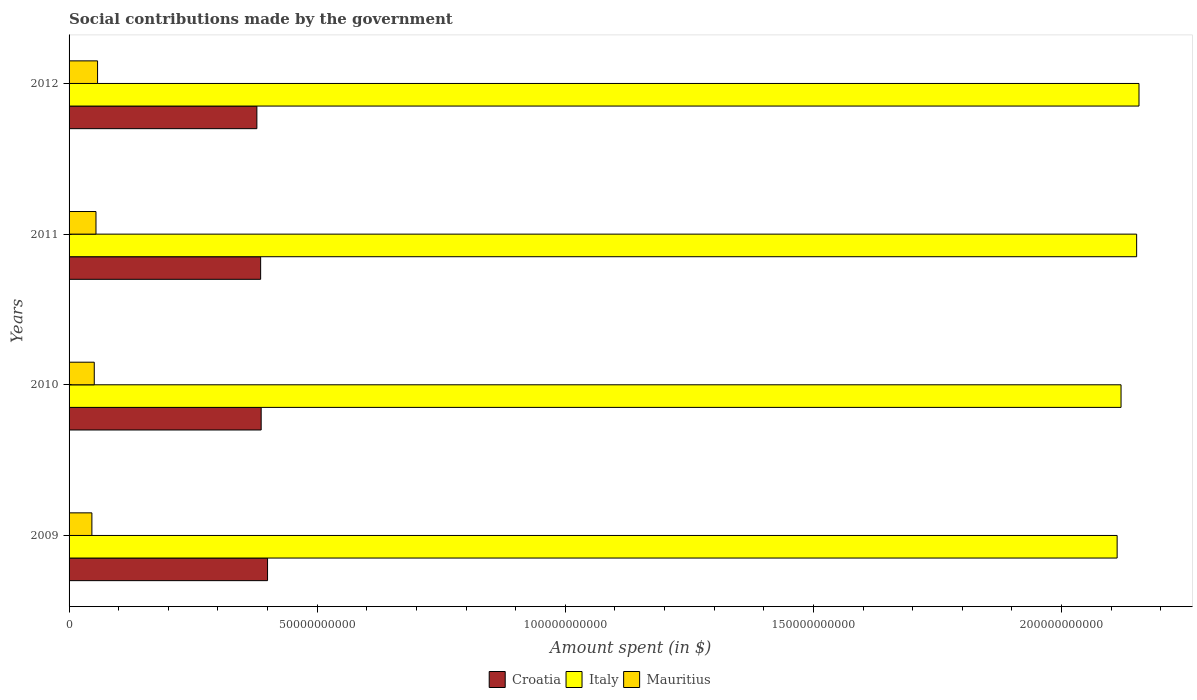How many groups of bars are there?
Give a very brief answer. 4. What is the label of the 4th group of bars from the top?
Give a very brief answer. 2009. What is the amount spent on social contributions in Italy in 2012?
Provide a succinct answer. 2.16e+11. Across all years, what is the maximum amount spent on social contributions in Croatia?
Your answer should be compact. 4.00e+1. Across all years, what is the minimum amount spent on social contributions in Croatia?
Provide a short and direct response. 3.78e+1. In which year was the amount spent on social contributions in Croatia maximum?
Keep it short and to the point. 2009. In which year was the amount spent on social contributions in Mauritius minimum?
Provide a short and direct response. 2009. What is the total amount spent on social contributions in Mauritius in the graph?
Your answer should be compact. 2.08e+1. What is the difference between the amount spent on social contributions in Mauritius in 2009 and that in 2012?
Offer a very short reply. -1.15e+09. What is the difference between the amount spent on social contributions in Croatia in 2010 and the amount spent on social contributions in Italy in 2009?
Offer a very short reply. -1.72e+11. What is the average amount spent on social contributions in Mauritius per year?
Give a very brief answer. 5.21e+09. In the year 2012, what is the difference between the amount spent on social contributions in Italy and amount spent on social contributions in Mauritius?
Your answer should be compact. 2.10e+11. What is the ratio of the amount spent on social contributions in Croatia in 2010 to that in 2012?
Ensure brevity in your answer.  1.02. What is the difference between the highest and the second highest amount spent on social contributions in Croatia?
Provide a short and direct response. 1.28e+09. What is the difference between the highest and the lowest amount spent on social contributions in Italy?
Offer a terse response. 4.40e+09. In how many years, is the amount spent on social contributions in Mauritius greater than the average amount spent on social contributions in Mauritius taken over all years?
Offer a very short reply. 2. Is the sum of the amount spent on social contributions in Mauritius in 2009 and 2010 greater than the maximum amount spent on social contributions in Croatia across all years?
Keep it short and to the point. No. What does the 1st bar from the top in 2009 represents?
Your answer should be very brief. Mauritius. What does the 1st bar from the bottom in 2010 represents?
Your response must be concise. Croatia. Is it the case that in every year, the sum of the amount spent on social contributions in Italy and amount spent on social contributions in Croatia is greater than the amount spent on social contributions in Mauritius?
Offer a very short reply. Yes. Does the graph contain any zero values?
Offer a terse response. No. How many legend labels are there?
Offer a terse response. 3. What is the title of the graph?
Offer a terse response. Social contributions made by the government. Does "Cameroon" appear as one of the legend labels in the graph?
Ensure brevity in your answer.  No. What is the label or title of the X-axis?
Provide a succinct answer. Amount spent (in $). What is the label or title of the Y-axis?
Ensure brevity in your answer.  Years. What is the Amount spent (in $) in Croatia in 2009?
Ensure brevity in your answer.  4.00e+1. What is the Amount spent (in $) in Italy in 2009?
Offer a terse response. 2.11e+11. What is the Amount spent (in $) in Mauritius in 2009?
Your answer should be very brief. 4.60e+09. What is the Amount spent (in $) in Croatia in 2010?
Provide a short and direct response. 3.87e+1. What is the Amount spent (in $) in Italy in 2010?
Ensure brevity in your answer.  2.12e+11. What is the Amount spent (in $) of Mauritius in 2010?
Your answer should be compact. 5.08e+09. What is the Amount spent (in $) of Croatia in 2011?
Offer a terse response. 3.86e+1. What is the Amount spent (in $) in Italy in 2011?
Your answer should be compact. 2.15e+11. What is the Amount spent (in $) in Mauritius in 2011?
Make the answer very short. 5.42e+09. What is the Amount spent (in $) of Croatia in 2012?
Provide a succinct answer. 3.78e+1. What is the Amount spent (in $) in Italy in 2012?
Provide a succinct answer. 2.16e+11. What is the Amount spent (in $) in Mauritius in 2012?
Provide a short and direct response. 5.74e+09. Across all years, what is the maximum Amount spent (in $) of Croatia?
Your answer should be compact. 4.00e+1. Across all years, what is the maximum Amount spent (in $) of Italy?
Your answer should be compact. 2.16e+11. Across all years, what is the maximum Amount spent (in $) of Mauritius?
Give a very brief answer. 5.74e+09. Across all years, what is the minimum Amount spent (in $) in Croatia?
Offer a terse response. 3.78e+1. Across all years, what is the minimum Amount spent (in $) of Italy?
Your answer should be compact. 2.11e+11. Across all years, what is the minimum Amount spent (in $) in Mauritius?
Offer a terse response. 4.60e+09. What is the total Amount spent (in $) of Croatia in the graph?
Make the answer very short. 1.55e+11. What is the total Amount spent (in $) of Italy in the graph?
Your response must be concise. 8.54e+11. What is the total Amount spent (in $) of Mauritius in the graph?
Keep it short and to the point. 2.08e+1. What is the difference between the Amount spent (in $) in Croatia in 2009 and that in 2010?
Your response must be concise. 1.28e+09. What is the difference between the Amount spent (in $) in Italy in 2009 and that in 2010?
Your response must be concise. -7.86e+08. What is the difference between the Amount spent (in $) in Mauritius in 2009 and that in 2010?
Provide a succinct answer. -4.80e+08. What is the difference between the Amount spent (in $) in Croatia in 2009 and that in 2011?
Provide a succinct answer. 1.39e+09. What is the difference between the Amount spent (in $) of Italy in 2009 and that in 2011?
Make the answer very short. -3.93e+09. What is the difference between the Amount spent (in $) of Mauritius in 2009 and that in 2011?
Provide a short and direct response. -8.24e+08. What is the difference between the Amount spent (in $) in Croatia in 2009 and that in 2012?
Ensure brevity in your answer.  2.15e+09. What is the difference between the Amount spent (in $) of Italy in 2009 and that in 2012?
Provide a succinct answer. -4.40e+09. What is the difference between the Amount spent (in $) in Mauritius in 2009 and that in 2012?
Your answer should be very brief. -1.15e+09. What is the difference between the Amount spent (in $) of Croatia in 2010 and that in 2011?
Give a very brief answer. 1.07e+08. What is the difference between the Amount spent (in $) of Italy in 2010 and that in 2011?
Keep it short and to the point. -3.14e+09. What is the difference between the Amount spent (in $) in Mauritius in 2010 and that in 2011?
Give a very brief answer. -3.45e+08. What is the difference between the Amount spent (in $) of Croatia in 2010 and that in 2012?
Give a very brief answer. 8.67e+08. What is the difference between the Amount spent (in $) in Italy in 2010 and that in 2012?
Provide a short and direct response. -3.62e+09. What is the difference between the Amount spent (in $) of Mauritius in 2010 and that in 2012?
Offer a terse response. -6.65e+08. What is the difference between the Amount spent (in $) in Croatia in 2011 and that in 2012?
Your answer should be very brief. 7.59e+08. What is the difference between the Amount spent (in $) in Italy in 2011 and that in 2012?
Your response must be concise. -4.74e+08. What is the difference between the Amount spent (in $) of Mauritius in 2011 and that in 2012?
Your answer should be compact. -3.21e+08. What is the difference between the Amount spent (in $) of Croatia in 2009 and the Amount spent (in $) of Italy in 2010?
Ensure brevity in your answer.  -1.72e+11. What is the difference between the Amount spent (in $) in Croatia in 2009 and the Amount spent (in $) in Mauritius in 2010?
Keep it short and to the point. 3.49e+1. What is the difference between the Amount spent (in $) in Italy in 2009 and the Amount spent (in $) in Mauritius in 2010?
Provide a succinct answer. 2.06e+11. What is the difference between the Amount spent (in $) in Croatia in 2009 and the Amount spent (in $) in Italy in 2011?
Offer a very short reply. -1.75e+11. What is the difference between the Amount spent (in $) of Croatia in 2009 and the Amount spent (in $) of Mauritius in 2011?
Keep it short and to the point. 3.46e+1. What is the difference between the Amount spent (in $) in Italy in 2009 and the Amount spent (in $) in Mauritius in 2011?
Your answer should be compact. 2.06e+11. What is the difference between the Amount spent (in $) of Croatia in 2009 and the Amount spent (in $) of Italy in 2012?
Keep it short and to the point. -1.76e+11. What is the difference between the Amount spent (in $) in Croatia in 2009 and the Amount spent (in $) in Mauritius in 2012?
Your response must be concise. 3.43e+1. What is the difference between the Amount spent (in $) in Italy in 2009 and the Amount spent (in $) in Mauritius in 2012?
Provide a short and direct response. 2.05e+11. What is the difference between the Amount spent (in $) in Croatia in 2010 and the Amount spent (in $) in Italy in 2011?
Keep it short and to the point. -1.76e+11. What is the difference between the Amount spent (in $) of Croatia in 2010 and the Amount spent (in $) of Mauritius in 2011?
Give a very brief answer. 3.33e+1. What is the difference between the Amount spent (in $) in Italy in 2010 and the Amount spent (in $) in Mauritius in 2011?
Keep it short and to the point. 2.07e+11. What is the difference between the Amount spent (in $) in Croatia in 2010 and the Amount spent (in $) in Italy in 2012?
Your answer should be compact. -1.77e+11. What is the difference between the Amount spent (in $) of Croatia in 2010 and the Amount spent (in $) of Mauritius in 2012?
Offer a terse response. 3.30e+1. What is the difference between the Amount spent (in $) in Italy in 2010 and the Amount spent (in $) in Mauritius in 2012?
Give a very brief answer. 2.06e+11. What is the difference between the Amount spent (in $) in Croatia in 2011 and the Amount spent (in $) in Italy in 2012?
Make the answer very short. -1.77e+11. What is the difference between the Amount spent (in $) in Croatia in 2011 and the Amount spent (in $) in Mauritius in 2012?
Your answer should be compact. 3.29e+1. What is the difference between the Amount spent (in $) in Italy in 2011 and the Amount spent (in $) in Mauritius in 2012?
Your response must be concise. 2.09e+11. What is the average Amount spent (in $) in Croatia per year?
Provide a short and direct response. 3.88e+1. What is the average Amount spent (in $) in Italy per year?
Provide a short and direct response. 2.13e+11. What is the average Amount spent (in $) of Mauritius per year?
Make the answer very short. 5.21e+09. In the year 2009, what is the difference between the Amount spent (in $) of Croatia and Amount spent (in $) of Italy?
Offer a terse response. -1.71e+11. In the year 2009, what is the difference between the Amount spent (in $) in Croatia and Amount spent (in $) in Mauritius?
Offer a very short reply. 3.54e+1. In the year 2009, what is the difference between the Amount spent (in $) of Italy and Amount spent (in $) of Mauritius?
Your response must be concise. 2.07e+11. In the year 2010, what is the difference between the Amount spent (in $) of Croatia and Amount spent (in $) of Italy?
Make the answer very short. -1.73e+11. In the year 2010, what is the difference between the Amount spent (in $) in Croatia and Amount spent (in $) in Mauritius?
Your response must be concise. 3.36e+1. In the year 2010, what is the difference between the Amount spent (in $) in Italy and Amount spent (in $) in Mauritius?
Your answer should be compact. 2.07e+11. In the year 2011, what is the difference between the Amount spent (in $) in Croatia and Amount spent (in $) in Italy?
Make the answer very short. -1.77e+11. In the year 2011, what is the difference between the Amount spent (in $) in Croatia and Amount spent (in $) in Mauritius?
Your answer should be compact. 3.32e+1. In the year 2011, what is the difference between the Amount spent (in $) in Italy and Amount spent (in $) in Mauritius?
Offer a very short reply. 2.10e+11. In the year 2012, what is the difference between the Amount spent (in $) of Croatia and Amount spent (in $) of Italy?
Offer a very short reply. -1.78e+11. In the year 2012, what is the difference between the Amount spent (in $) of Croatia and Amount spent (in $) of Mauritius?
Offer a very short reply. 3.21e+1. In the year 2012, what is the difference between the Amount spent (in $) of Italy and Amount spent (in $) of Mauritius?
Provide a succinct answer. 2.10e+11. What is the ratio of the Amount spent (in $) in Croatia in 2009 to that in 2010?
Offer a terse response. 1.03. What is the ratio of the Amount spent (in $) of Mauritius in 2009 to that in 2010?
Provide a short and direct response. 0.91. What is the ratio of the Amount spent (in $) of Croatia in 2009 to that in 2011?
Your answer should be compact. 1.04. What is the ratio of the Amount spent (in $) in Italy in 2009 to that in 2011?
Provide a short and direct response. 0.98. What is the ratio of the Amount spent (in $) of Mauritius in 2009 to that in 2011?
Your response must be concise. 0.85. What is the ratio of the Amount spent (in $) in Croatia in 2009 to that in 2012?
Give a very brief answer. 1.06. What is the ratio of the Amount spent (in $) of Italy in 2009 to that in 2012?
Your response must be concise. 0.98. What is the ratio of the Amount spent (in $) in Mauritius in 2009 to that in 2012?
Make the answer very short. 0.8. What is the ratio of the Amount spent (in $) in Italy in 2010 to that in 2011?
Your answer should be very brief. 0.99. What is the ratio of the Amount spent (in $) of Mauritius in 2010 to that in 2011?
Offer a terse response. 0.94. What is the ratio of the Amount spent (in $) in Croatia in 2010 to that in 2012?
Provide a short and direct response. 1.02. What is the ratio of the Amount spent (in $) in Italy in 2010 to that in 2012?
Give a very brief answer. 0.98. What is the ratio of the Amount spent (in $) of Mauritius in 2010 to that in 2012?
Your answer should be very brief. 0.88. What is the ratio of the Amount spent (in $) in Croatia in 2011 to that in 2012?
Make the answer very short. 1.02. What is the ratio of the Amount spent (in $) in Italy in 2011 to that in 2012?
Give a very brief answer. 1. What is the ratio of the Amount spent (in $) in Mauritius in 2011 to that in 2012?
Provide a short and direct response. 0.94. What is the difference between the highest and the second highest Amount spent (in $) of Croatia?
Make the answer very short. 1.28e+09. What is the difference between the highest and the second highest Amount spent (in $) in Italy?
Keep it short and to the point. 4.74e+08. What is the difference between the highest and the second highest Amount spent (in $) of Mauritius?
Offer a terse response. 3.21e+08. What is the difference between the highest and the lowest Amount spent (in $) of Croatia?
Provide a short and direct response. 2.15e+09. What is the difference between the highest and the lowest Amount spent (in $) in Italy?
Ensure brevity in your answer.  4.40e+09. What is the difference between the highest and the lowest Amount spent (in $) in Mauritius?
Your answer should be very brief. 1.15e+09. 